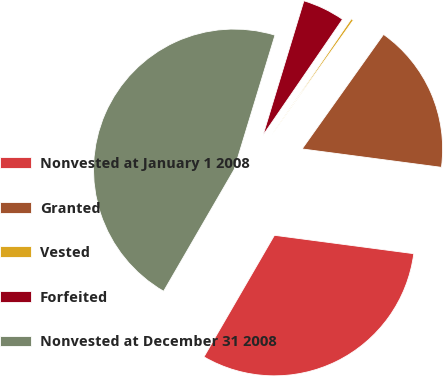Convert chart. <chart><loc_0><loc_0><loc_500><loc_500><pie_chart><fcel>Nonvested at January 1 2008<fcel>Granted<fcel>Vested<fcel>Forfeited<fcel>Nonvested at December 31 2008<nl><fcel>31.27%<fcel>17.25%<fcel>0.27%<fcel>4.87%<fcel>46.34%<nl></chart> 